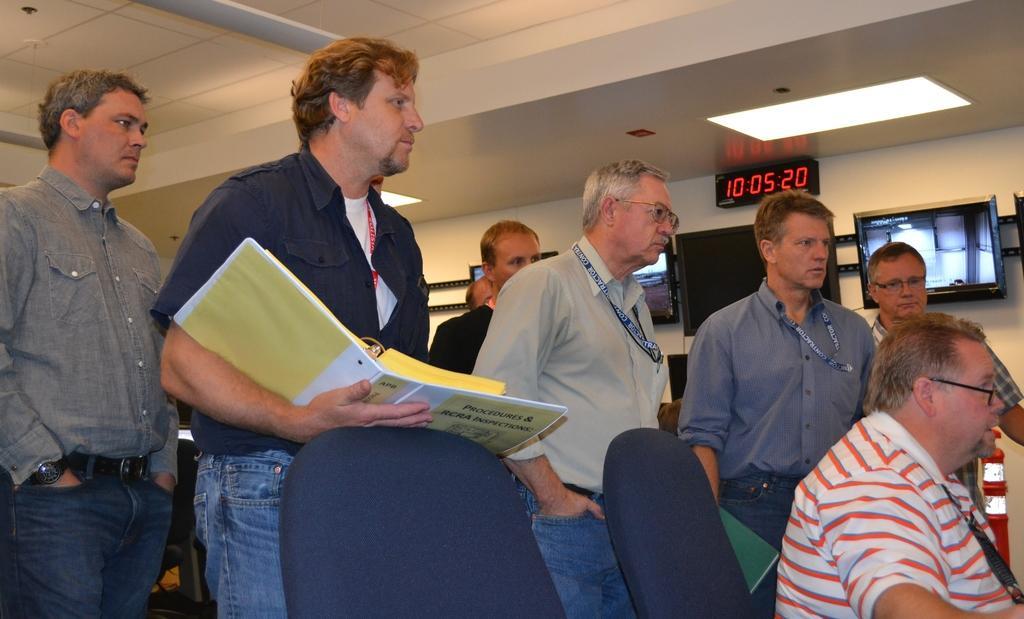Describe this image in one or two sentences. In this picture we can see a group of people standing and a man sitting on a chair, books and in the background we can see televisions, lights, wall. 